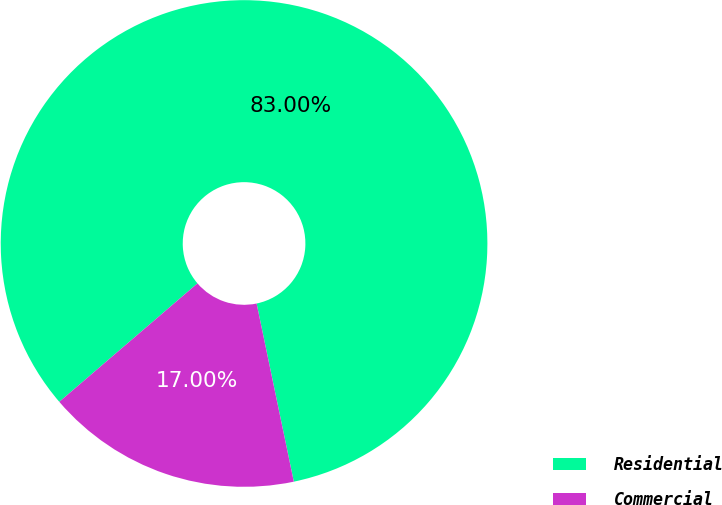Convert chart. <chart><loc_0><loc_0><loc_500><loc_500><pie_chart><fcel>Residential<fcel>Commercial<nl><fcel>83.0%<fcel>17.0%<nl></chart> 